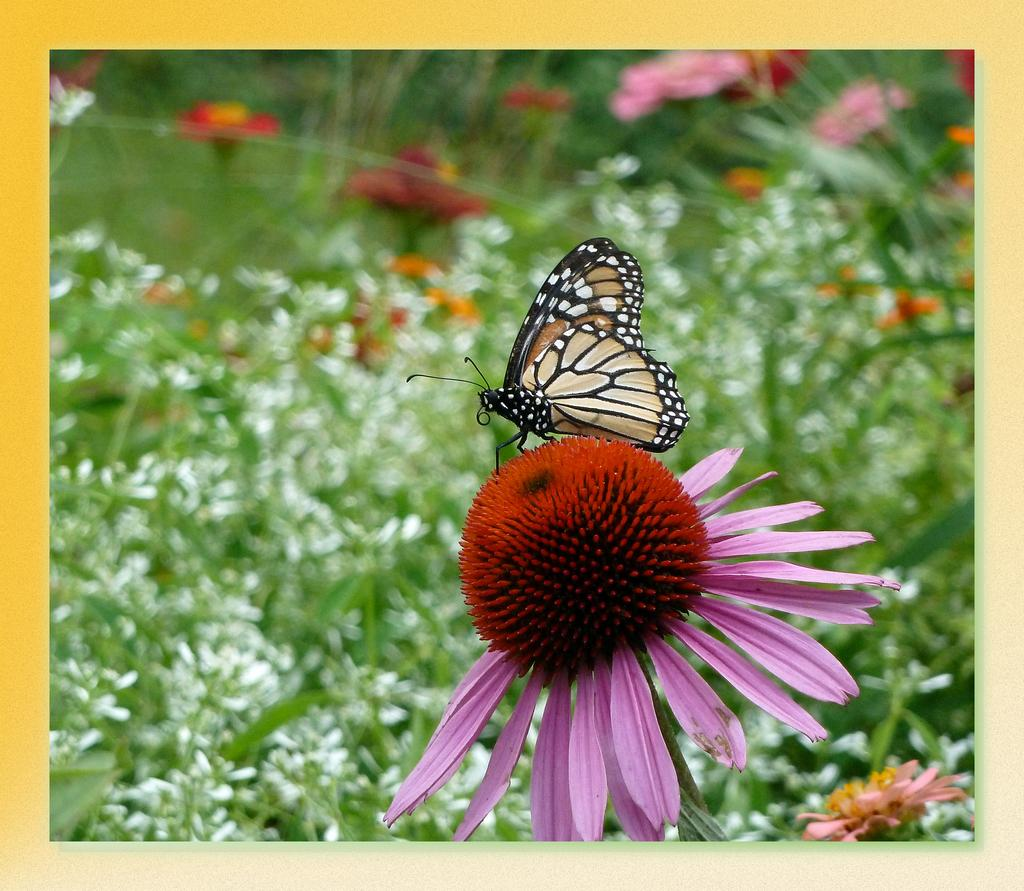What is the main subject of the image? There is a butterfly in the image. Where is the butterfly located? The butterfly is on a flower. What can be seen in the background of the image? There are flowers and plants in the background of the image. What type of stamp can be seen on the page in the image? There is no page or stamp present in the image; it features a butterfly on a flower with flowers and plants in the background. 